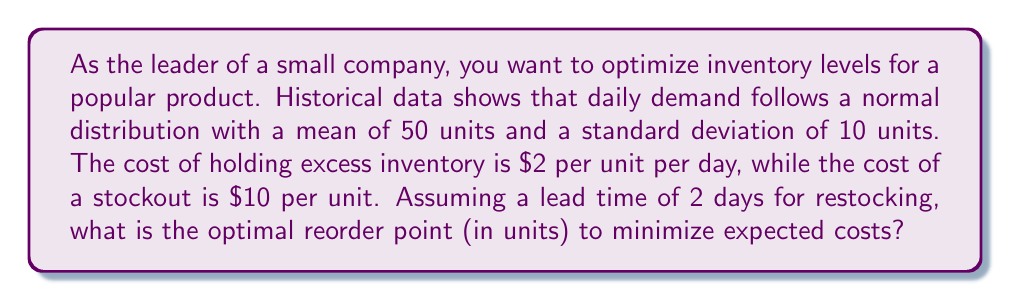Can you solve this math problem? To solve this problem, we'll use the concept of the safety stock and the normal distribution properties.

Step 1: Determine the service level
The optimal service level balances the cost of overstocking against the cost of stockouts. It's given by:
$$\text{Service Level} = \frac{\text{Stockout Cost}}{\text{Stockout Cost} + \text{Holding Cost}} = \frac{10}{10 + 2} = 0.8333$$

Step 2: Find the z-score for the service level
Using a standard normal distribution table or calculator, we find that a service level of 0.8333 corresponds to a z-score of approximately 0.97.

Step 3: Calculate the safety stock
Safety stock is given by:
$$\text{Safety Stock} = z \cdot \sigma \cdot \sqrt{\text{Lead Time}}$$
Where $z$ is the z-score, $\sigma$ is the standard deviation of daily demand, and lead time is in days.
$$\text{Safety Stock} = 0.97 \cdot 10 \cdot \sqrt{2} = 13.71 \text{ units}$$

Step 4: Calculate the reorder point
The reorder point is the sum of the expected demand during lead time plus the safety stock:
$$\text{Reorder Point} = (\text{Mean Daily Demand} \cdot \text{Lead Time}) + \text{Safety Stock}$$
$$\text{Reorder Point} = (50 \cdot 2) + 13.71 = 113.71 \text{ units}$$

Step 5: Round to the nearest whole number
Since we can't order fractional units, we round up to 114 units.
Answer: 114 units 